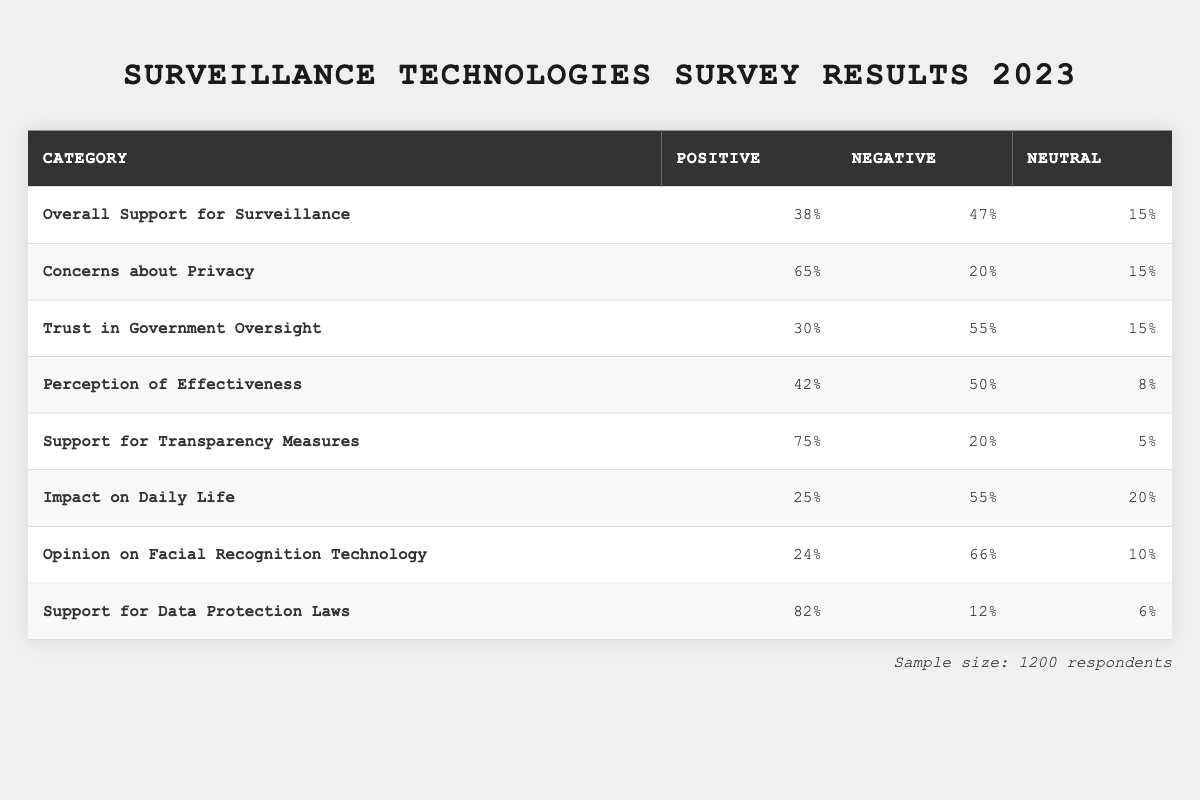What percentage of respondents opposed surveillance? The table shows that 47% of respondents opposed surveillance under the "Overall Support for Surveillance" category.
Answer: 47% What is the percentage of respondents who expressed high concern about privacy? According to the "Concerns about Privacy" category, 65% of respondents indicated high concern about privacy.
Answer: 65% What is the support percentage for transparency measures? The table indicates that 75% of respondents support transparency measures in the "Support for Transparency Measures" category.
Answer: 75% What percentage of respondents trust government oversight? The "Trust in Government Oversight" category reveals that only 30% of respondents trust government oversight.
Answer: 30% What is the difference between the percentages of those who perceive surveillance as effective and those who perceive it as ineffective? The effective percentage is 42%, and the ineffective percentage is 50%. The difference is 50% - 42% = 8%.
Answer: 8% What is the combined percentage of respondents who had a neutral opinion about facial recognition technology? The "Opinion on Facial Recognition Technology" category shows 10% neutral respondents.
Answer: 10% Does the majority of respondents support data protection laws? Yes, 82% of respondents support data protection laws, which is more than half.
Answer: Yes What percentage of respondents felt that surveillance had a negative impact on their daily life? The table shows that 55% of respondents believed surveillance had a negative impact on their daily lives.
Answer: 55% What is the percentage of respondents who are either neutral or support data protection laws? The support percentage is 82%, and the neutral percentage is 6%, so the combined percentage is 82% + 6% = 88%.
Answer: 88% Is there a greater percentage of respondents who oppose the use of facial recognition technology or those who support it? The opposition percentage stands at 66%, while the support percentage is 24%. Since 66% > 24%, more oppose than support.
Answer: Yes 